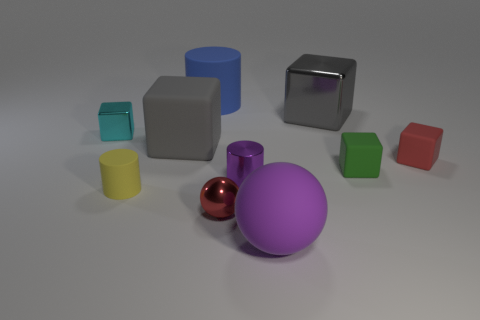Subtract all small green rubber blocks. How many blocks are left? 4 Subtract all yellow cylinders. How many cylinders are left? 2 Subtract 0 brown cubes. How many objects are left? 10 Subtract all cylinders. How many objects are left? 7 Subtract 3 cubes. How many cubes are left? 2 Subtract all brown cylinders. Subtract all cyan balls. How many cylinders are left? 3 Subtract all gray balls. How many gray blocks are left? 2 Subtract all tiny yellow metal cubes. Subtract all purple rubber objects. How many objects are left? 9 Add 3 red matte things. How many red matte things are left? 4 Add 1 large shiny objects. How many large shiny objects exist? 2 